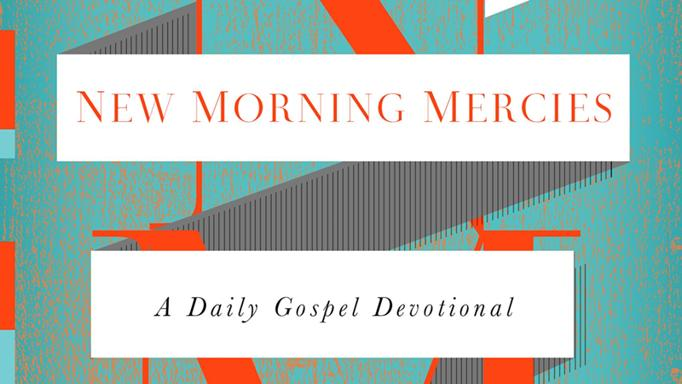Can you tell what the typographic style used in the title suggests about the nature of the devotional? The modern and bold typographic style used in the title of 'New Morning Mercies' suggests that the devotional is intended to be impactful and accessible. The use of strong, clear fonts conveys a sense of importance and clarity, likely aimed at drawing the reader's attention to the spiritual messages contained within. 